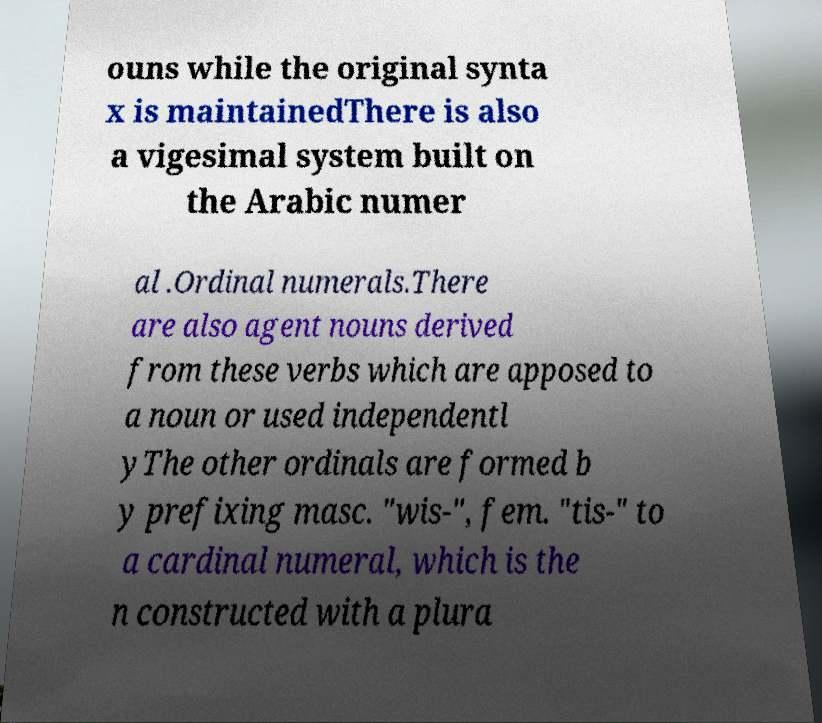Could you assist in decoding the text presented in this image and type it out clearly? ouns while the original synta x is maintainedThere is also a vigesimal system built on the Arabic numer al .Ordinal numerals.There are also agent nouns derived from these verbs which are apposed to a noun or used independentl yThe other ordinals are formed b y prefixing masc. "wis-", fem. "tis-" to a cardinal numeral, which is the n constructed with a plura 